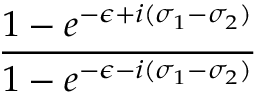<formula> <loc_0><loc_0><loc_500><loc_500>\frac { 1 - e ^ { - \epsilon + i ( \sigma _ { 1 } - \sigma _ { 2 } ) } } { 1 - e ^ { - \epsilon - i ( \sigma _ { 1 } - \sigma _ { 2 } ) } }</formula> 